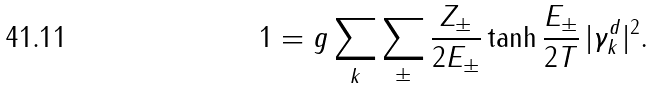Convert formula to latex. <formula><loc_0><loc_0><loc_500><loc_500>1 = g \sum _ { k } \sum _ { \pm } \frac { Z _ { \pm } } { 2 E _ { \pm } } \tanh \frac { E _ { \pm } } { 2 T } \, | \gamma _ { k } ^ { d } | ^ { 2 } .</formula> 